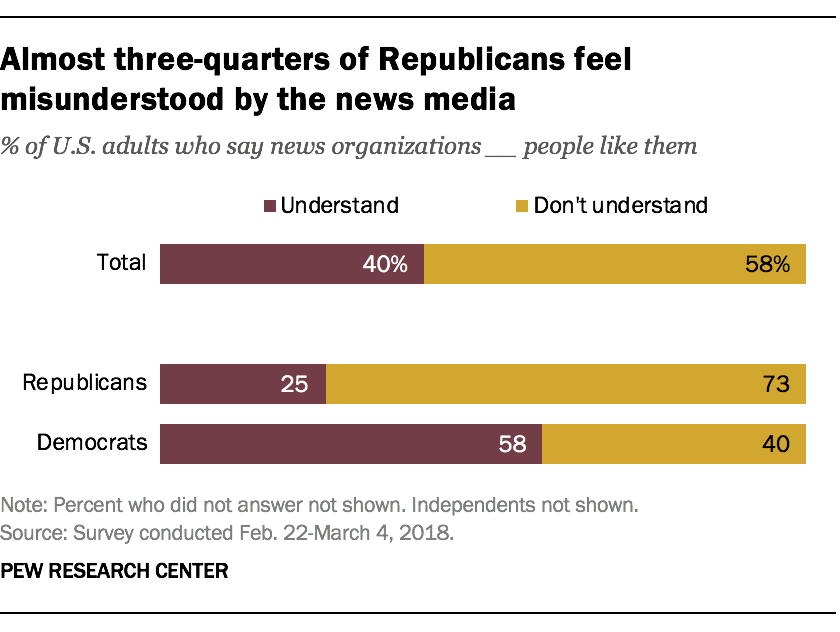Draw attention to some important aspects in this diagram. The ratio of the smallest purple and yellow bars is approximately 0.213888889. According to a survey, 40% of U.S. adults believe that news organizations understand people like them. 